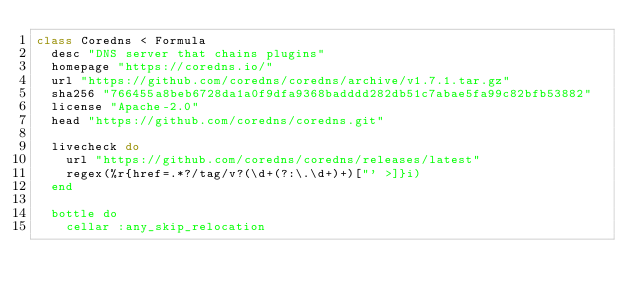<code> <loc_0><loc_0><loc_500><loc_500><_Ruby_>class Coredns < Formula
  desc "DNS server that chains plugins"
  homepage "https://coredns.io/"
  url "https://github.com/coredns/coredns/archive/v1.7.1.tar.gz"
  sha256 "766455a8beb6728da1a0f9dfa9368badddd282db51c7abae5fa99c82bfb53882"
  license "Apache-2.0"
  head "https://github.com/coredns/coredns.git"

  livecheck do
    url "https://github.com/coredns/coredns/releases/latest"
    regex(%r{href=.*?/tag/v?(\d+(?:\.\d+)+)["' >]}i)
  end

  bottle do
    cellar :any_skip_relocation</code> 